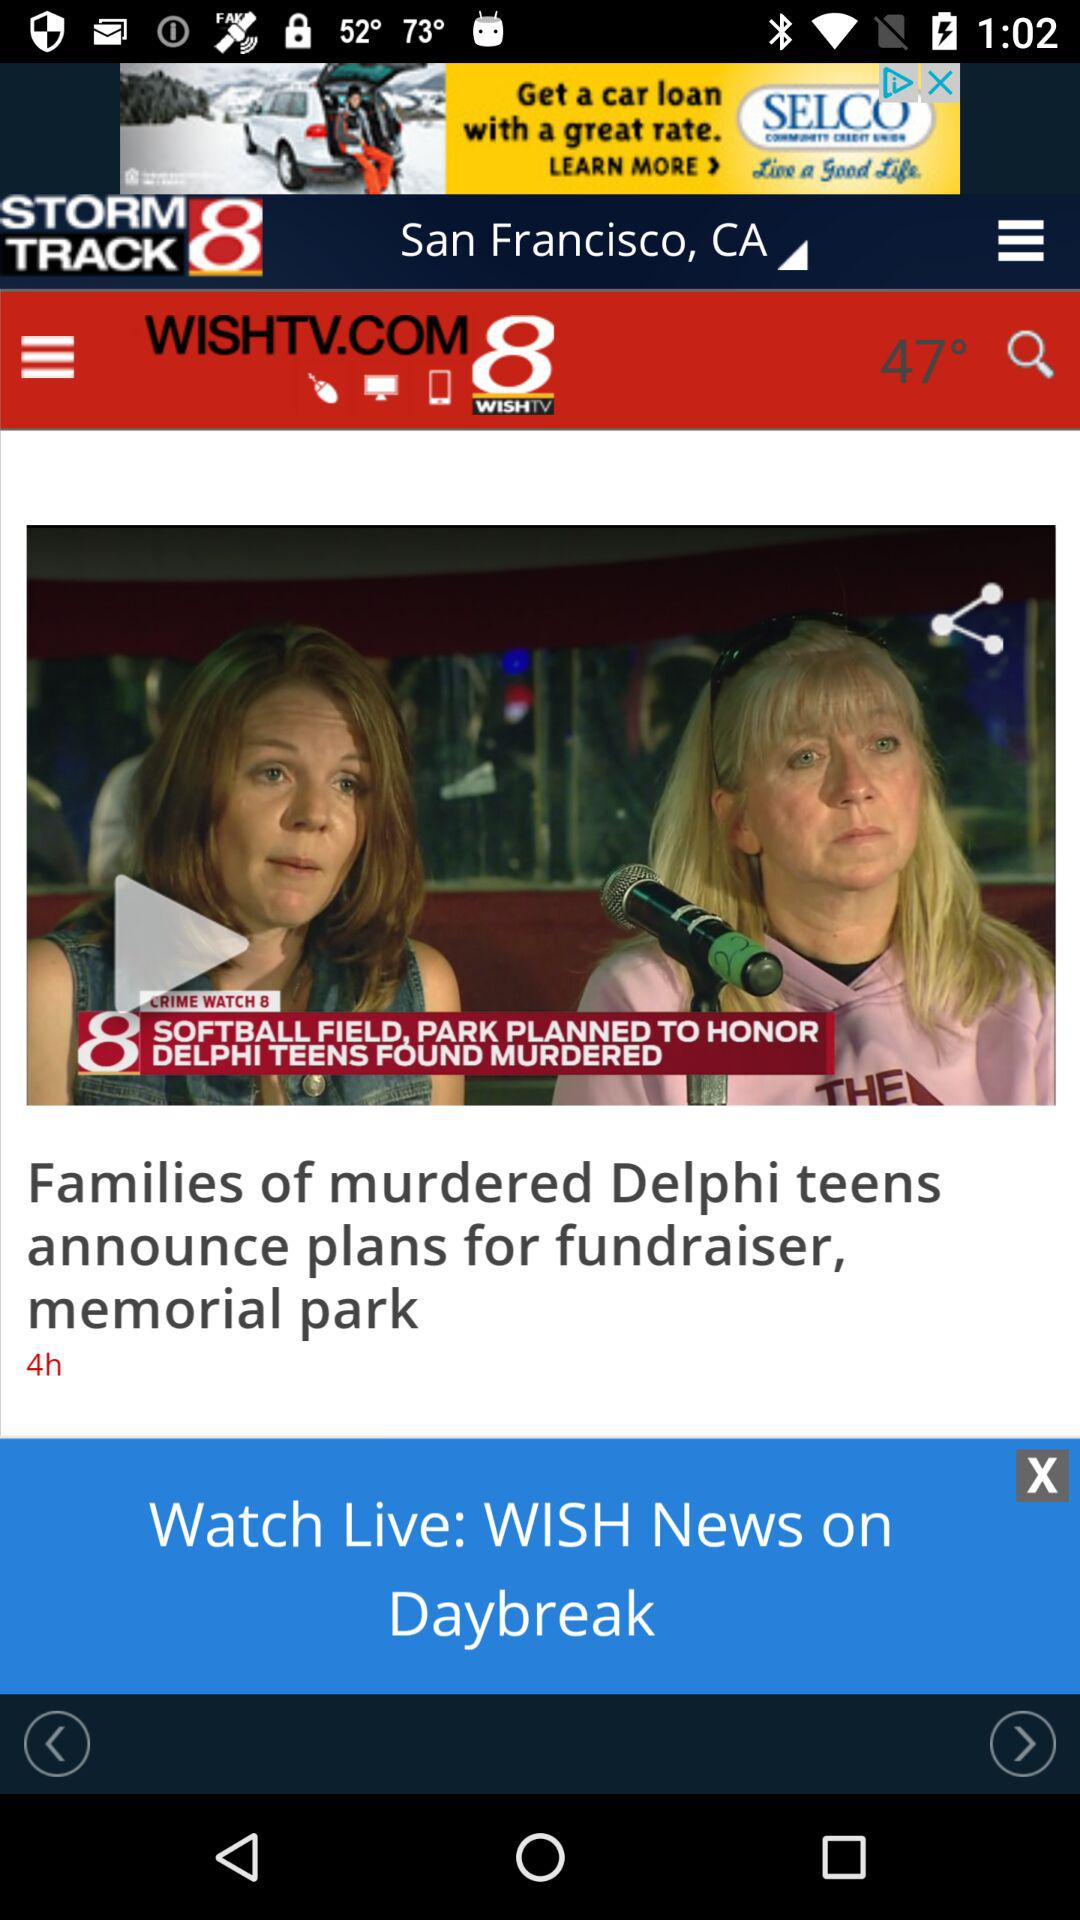What is the temperature shown on the screen? The temperature shown on the screen is 47 degrees. 